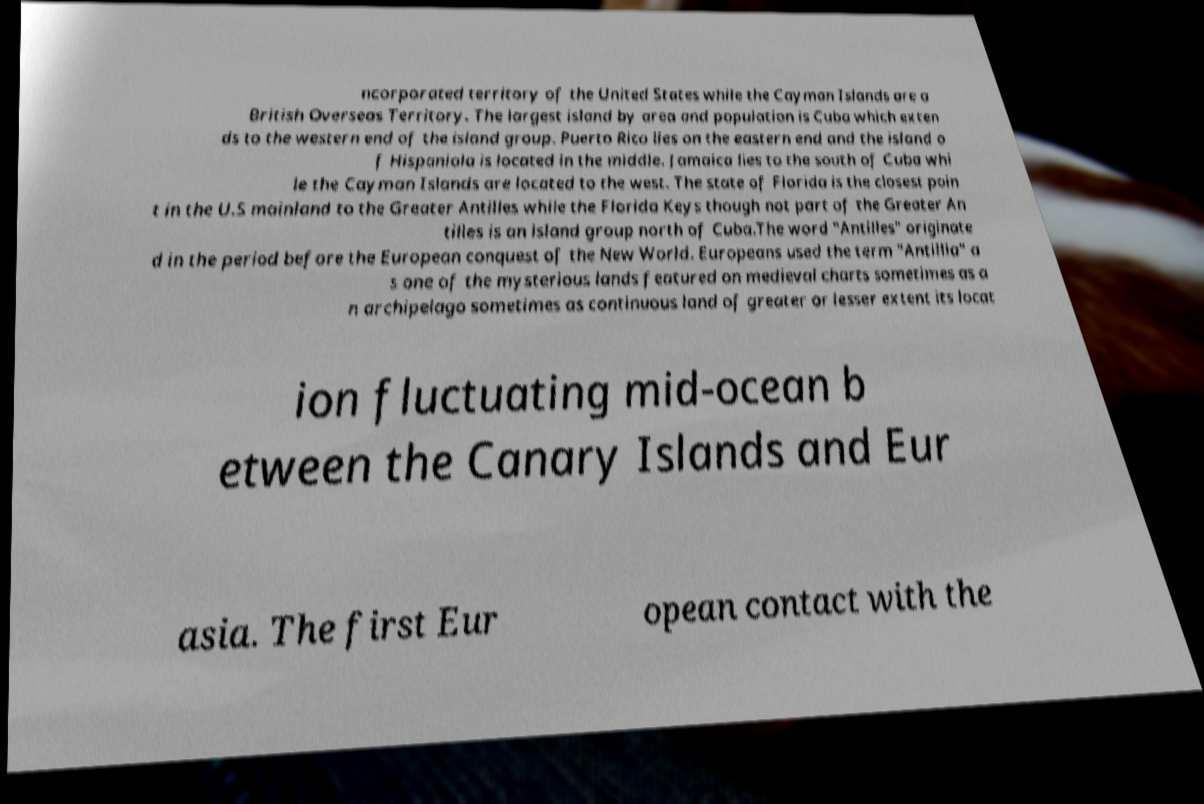What messages or text are displayed in this image? I need them in a readable, typed format. ncorporated territory of the United States while the Cayman Islands are a British Overseas Territory. The largest island by area and population is Cuba which exten ds to the western end of the island group. Puerto Rico lies on the eastern end and the island o f Hispaniola is located in the middle. Jamaica lies to the south of Cuba whi le the Cayman Islands are located to the west. The state of Florida is the closest poin t in the U.S mainland to the Greater Antilles while the Florida Keys though not part of the Greater An tilles is an island group north of Cuba.The word "Antilles" originate d in the period before the European conquest of the New World. Europeans used the term "Antillia" a s one of the mysterious lands featured on medieval charts sometimes as a n archipelago sometimes as continuous land of greater or lesser extent its locat ion fluctuating mid-ocean b etween the Canary Islands and Eur asia. The first Eur opean contact with the 